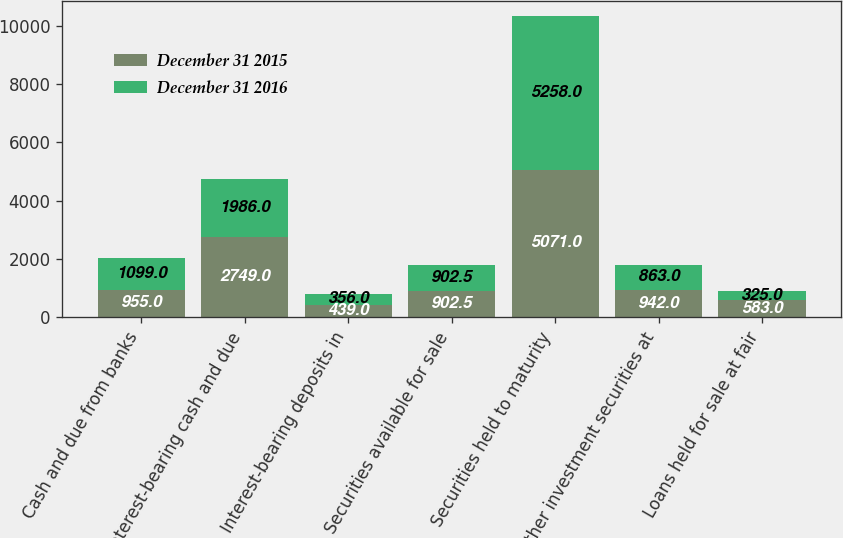Convert chart. <chart><loc_0><loc_0><loc_500><loc_500><stacked_bar_chart><ecel><fcel>Cash and due from banks<fcel>Interest-bearing cash and due<fcel>Interest-bearing deposits in<fcel>Securities available for sale<fcel>Securities held to maturity<fcel>Other investment securities at<fcel>Loans held for sale at fair<nl><fcel>December 31 2015<fcel>955<fcel>2749<fcel>439<fcel>902.5<fcel>5071<fcel>942<fcel>583<nl><fcel>December 31 2016<fcel>1099<fcel>1986<fcel>356<fcel>902.5<fcel>5258<fcel>863<fcel>325<nl></chart> 